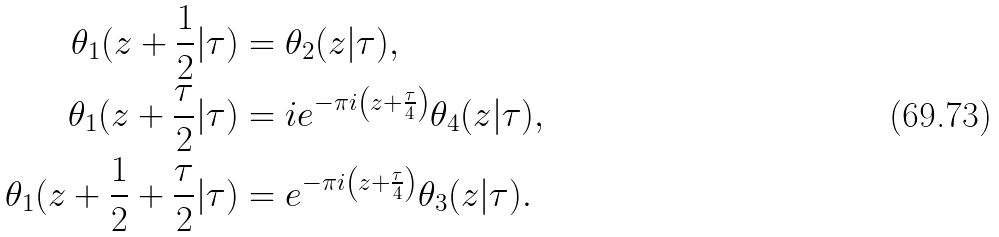<formula> <loc_0><loc_0><loc_500><loc_500>\theta _ { 1 } ( z + \frac { 1 } { 2 } | \tau ) & = \theta _ { 2 } ( z | \tau ) , \\ \theta _ { 1 } ( z + \frac { \tau } { 2 } | \tau ) & = i e ^ { - \pi i \left ( z + \frac { \tau } { 4 } \right ) } \theta _ { 4 } ( z | \tau ) , \\ \theta _ { 1 } ( z + \frac { 1 } { 2 } + \frac { \tau } { 2 } | \tau ) & = e ^ { - \pi i \left ( z + \frac { \tau } { 4 } \right ) } \theta _ { 3 } ( z | \tau ) .</formula> 